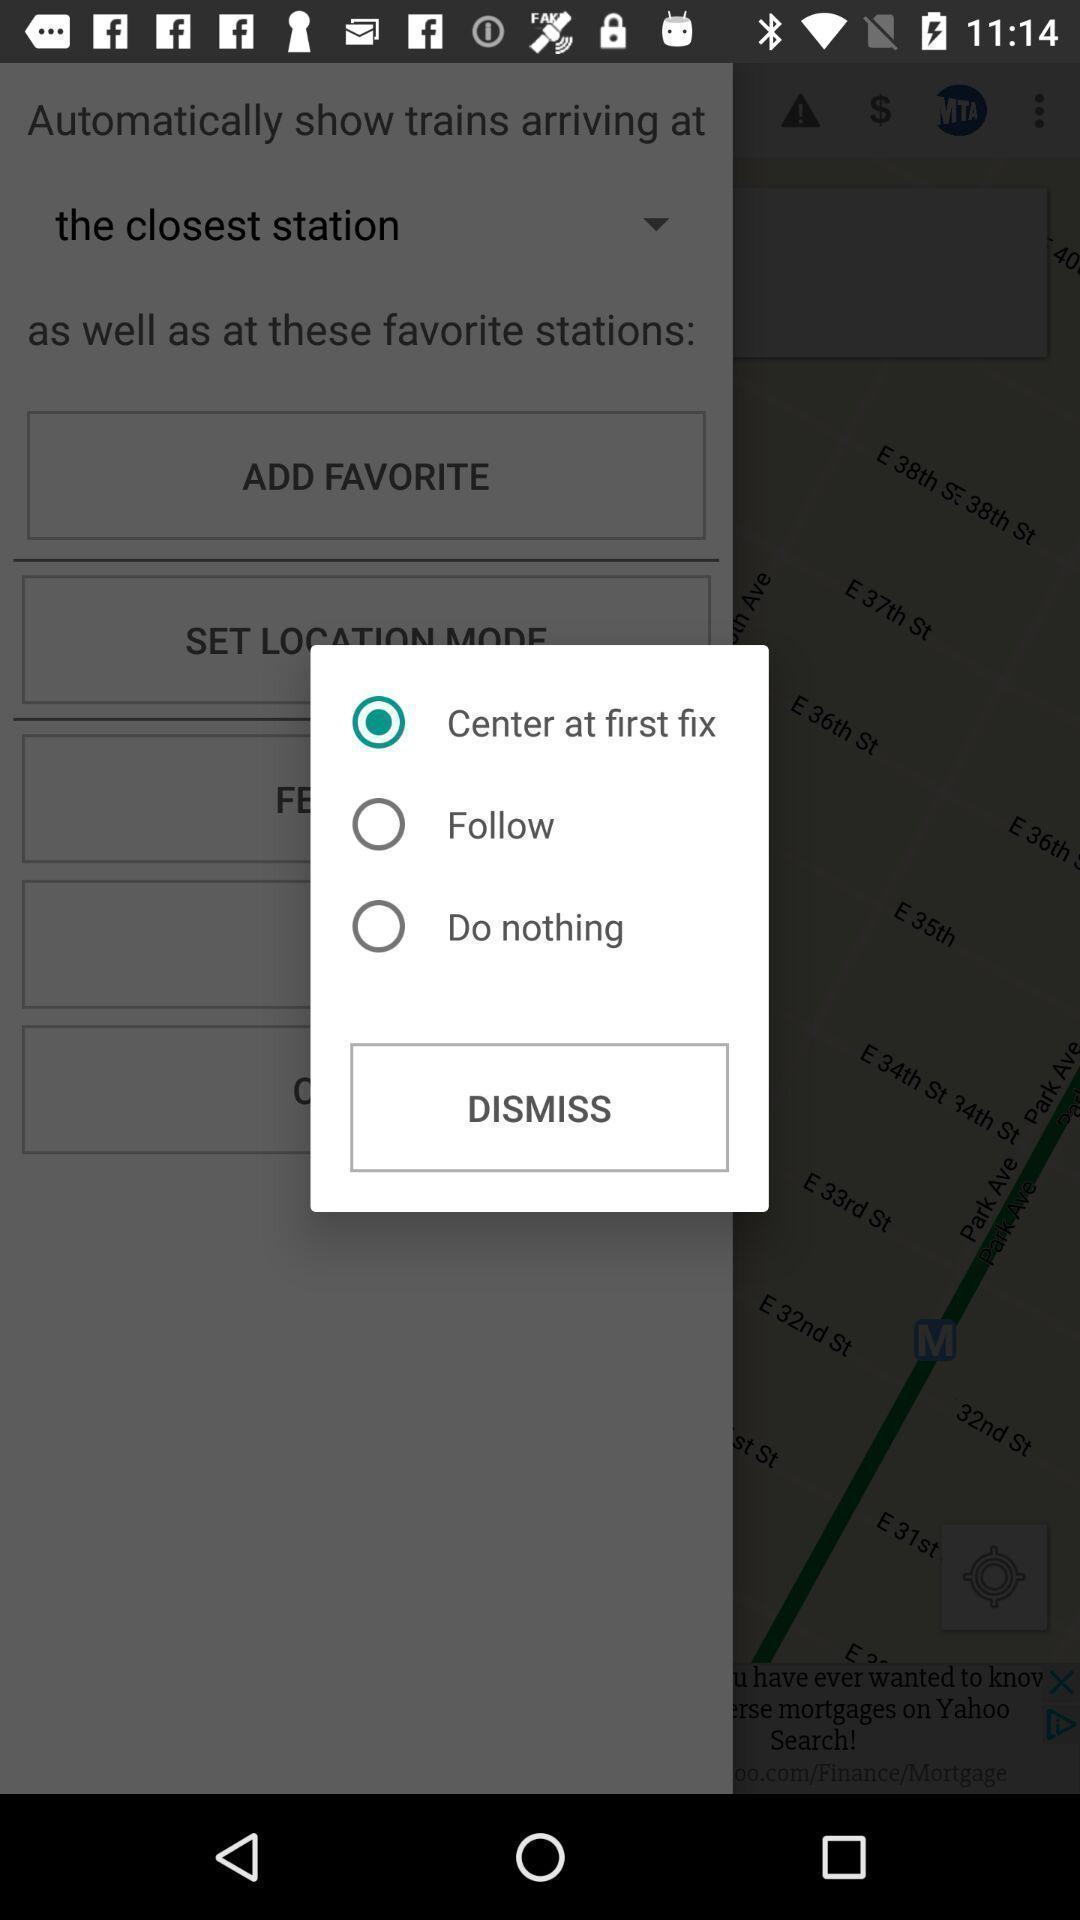Tell me about the visual elements in this screen capture. Pop-up showing three options with a cancel button. 